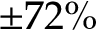<formula> <loc_0><loc_0><loc_500><loc_500>\pm 7 2 \%</formula> 